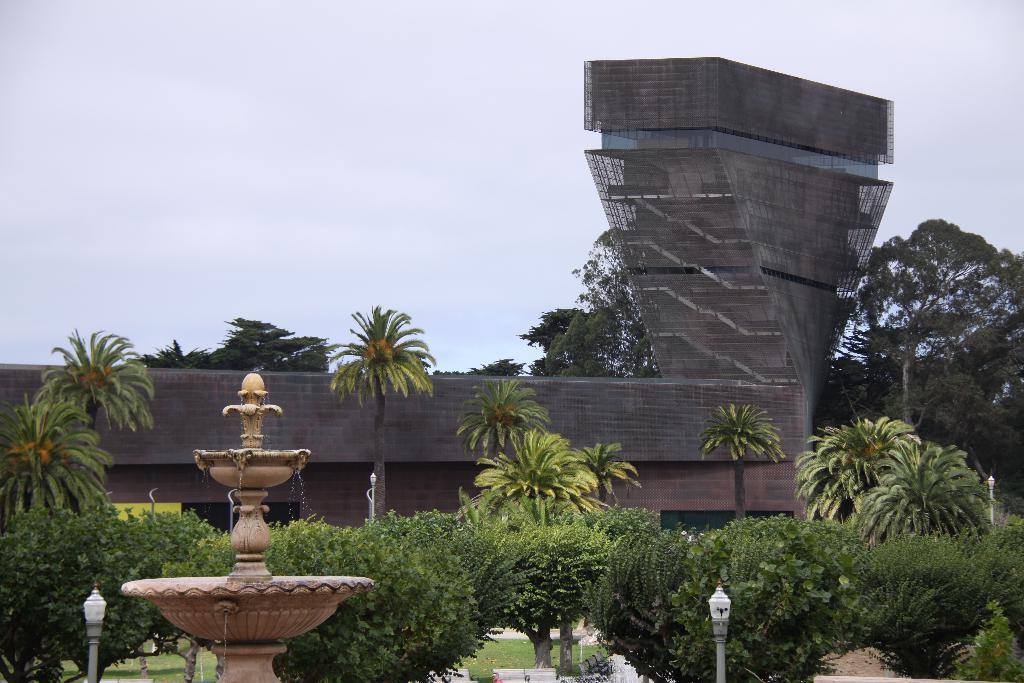What is located in the foreground of the image? There is a fountain, grass, plants, trees, and poles in the foreground of the image. What can be seen in the background of the image? There is a building and the sky visible in the background of the image. What is the time of day when the image might have been taken? The image might have been taken during the day, as suggested by the visible sky. What type of question is being asked by the egg in the image? There is no egg present in the image, and therefore no such question can be asked. Can you hear the voice of the person in the image? The image is silent, and there is no indication of any voice or sound. 